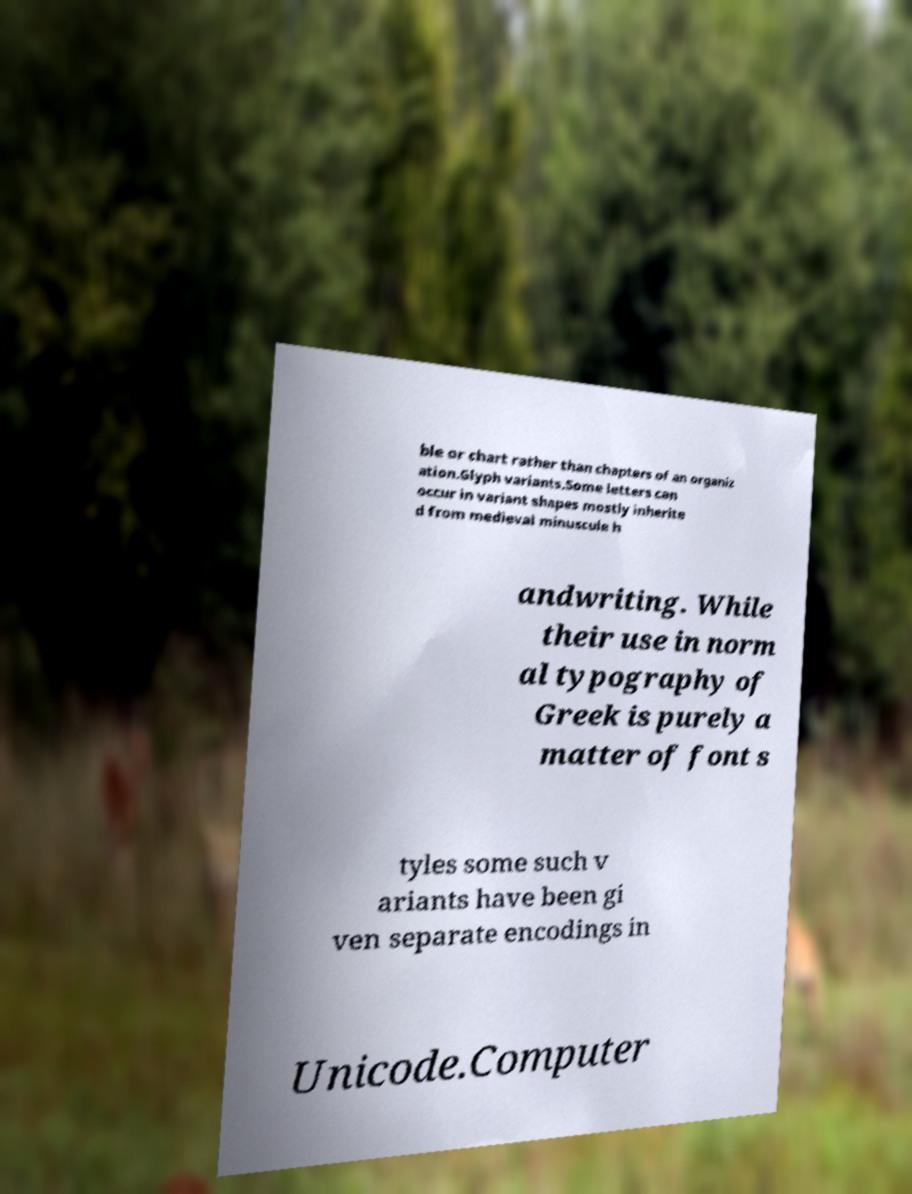Please read and relay the text visible in this image. What does it say? ble or chart rather than chapters of an organiz ation.Glyph variants.Some letters can occur in variant shapes mostly inherite d from medieval minuscule h andwriting. While their use in norm al typography of Greek is purely a matter of font s tyles some such v ariants have been gi ven separate encodings in Unicode.Computer 